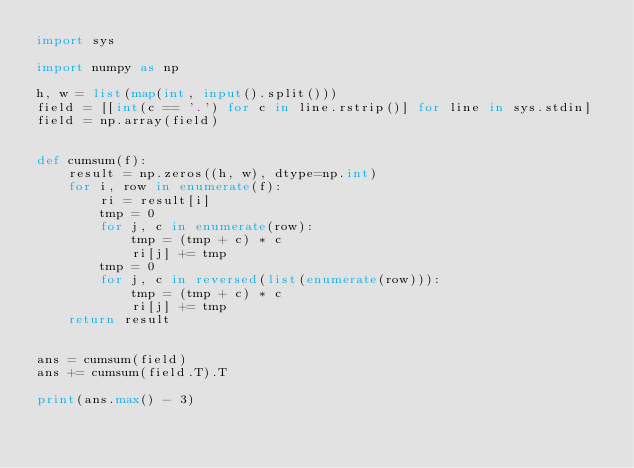<code> <loc_0><loc_0><loc_500><loc_500><_Python_>import sys

import numpy as np

h, w = list(map(int, input().split()))
field = [[int(c == '.') for c in line.rstrip()] for line in sys.stdin]
field = np.array(field)


def cumsum(f):
    result = np.zeros((h, w), dtype=np.int)
    for i, row in enumerate(f):
        ri = result[i]
        tmp = 0
        for j, c in enumerate(row):
            tmp = (tmp + c) * c
            ri[j] += tmp
        tmp = 0
        for j, c in reversed(list(enumerate(row))):
            tmp = (tmp + c) * c
            ri[j] += tmp
    return result


ans = cumsum(field)
ans += cumsum(field.T).T

print(ans.max() - 3)
</code> 